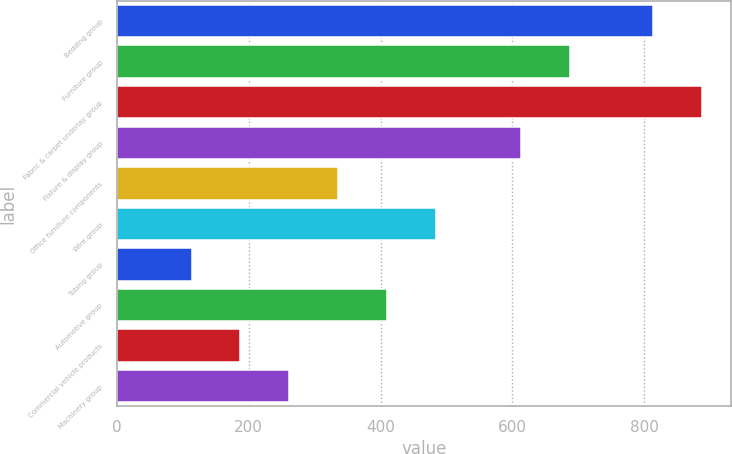<chart> <loc_0><loc_0><loc_500><loc_500><bar_chart><fcel>Bedding group<fcel>Furniture group<fcel>Fabric & carpet underlay group<fcel>Fixture & display group<fcel>Office furniture components<fcel>Wire group<fcel>Tubing group<fcel>Automotive group<fcel>Commercial vehicle products<fcel>Machinery group<nl><fcel>813.6<fcel>687.18<fcel>887.78<fcel>613<fcel>335.74<fcel>484.1<fcel>113.2<fcel>409.92<fcel>187.38<fcel>261.56<nl></chart> 